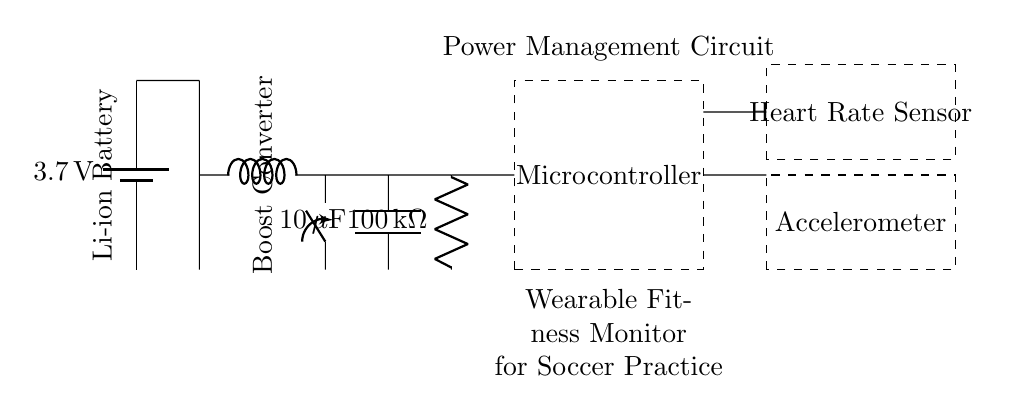What is the voltage of the battery? The circuit diagram shows a battery labeled with a voltage of 3.7 volts. This voltage is the nominal output that powers the circuit.
Answer: 3.7 volts What type of conversion is used in this circuit? The circuit includes a boost converter, which indicates that it is tasked with increasing the voltage from the battery to a level suitable for the microcontroller and sensors.
Answer: Boost conversion What is the capacitance of the capacitor? The circuit features a capacitor labeled with a value of 10 microfarads, indicating its capacitance, which helps in smoothing voltage levels.
Answer: 10 microfarads Which components are connected to the microcontroller? The connections at the dashed rectangle labeled 'Microcontroller' indicate that it is connected to resistors and the sensors, specifically the accelerometer and heart rate sensor, for data acquisition.
Answer: Resistors, accelerometer, heart rate sensor How does the power management support wearables? The arrangement indicates a system that provides stable power supply through a boost conversion process to maintain functionality during soccer practice, enhancing user experience in fitness monitoring.
Answer: Stable power supply What does the inductor do in this circuit? The inductor is a key component of the boost converter that stores energy when current flows through it and releases it to boost the voltage output needed for the devices.
Answer: Stores energy What are the two types of sensors used in this circuit? The circuit diagram labels two types of sensors: an accelerometer and a heart rate sensor, which are crucial for monitoring physical activities and physiological status during soccer practice.
Answer: Accelerometer and heart rate sensor 